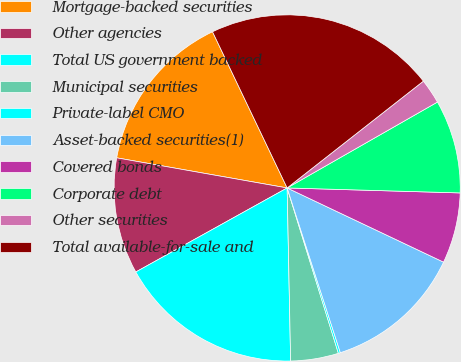<chart> <loc_0><loc_0><loc_500><loc_500><pie_chart><fcel>Mortgage-backed securities<fcel>Other agencies<fcel>Total US government backed<fcel>Municipal securities<fcel>Private-label CMO<fcel>Asset-backed securities(1)<fcel>Covered bonds<fcel>Corporate debt<fcel>Other securities<fcel>Total available-for-sale and<nl><fcel>15.12%<fcel>10.85%<fcel>17.25%<fcel>4.46%<fcel>0.19%<fcel>12.98%<fcel>6.59%<fcel>8.72%<fcel>2.32%<fcel>21.51%<nl></chart> 